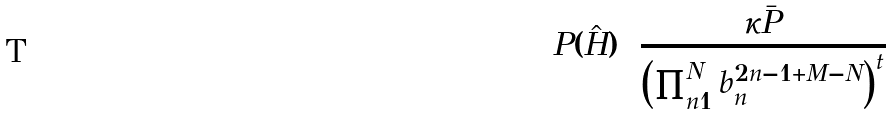Convert formula to latex. <formula><loc_0><loc_0><loc_500><loc_500>P ( \hat { H } ) = \frac { \kappa \bar { P } } { \left ( \prod _ { n = 1 } ^ { N } b _ { n } ^ { 2 n - 1 + M - N } \right ) ^ { t } }</formula> 